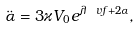Convert formula to latex. <formula><loc_0><loc_0><loc_500><loc_500>\ddot { \alpha } = 3 \varkappa V _ { 0 } e ^ { \lambda \ v f + 2 \alpha } ,</formula> 